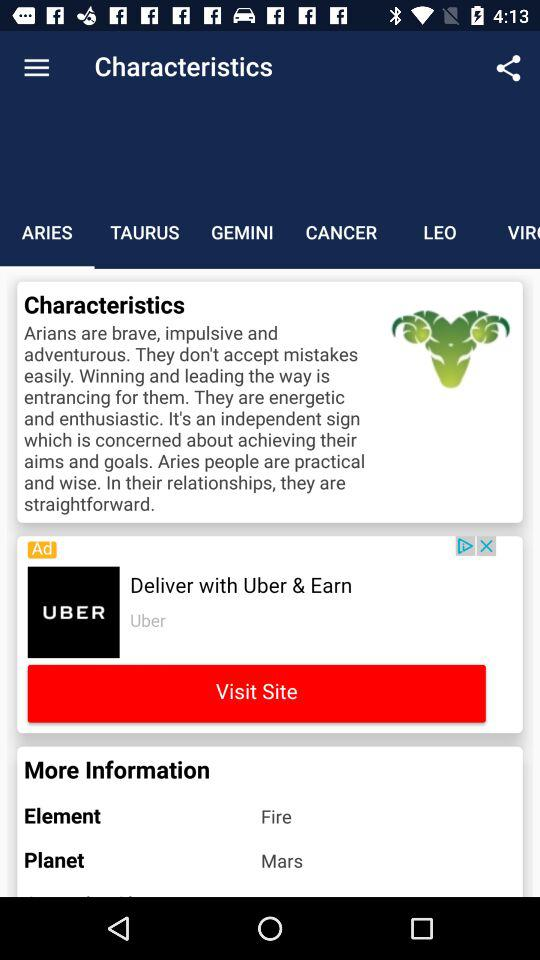Which element represents the Aries zodiac sign? The element that represents the Aries zodiac sign is "Fire". 